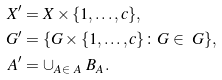Convert formula to latex. <formula><loc_0><loc_0><loc_500><loc_500>X ^ { \prime } & = X \times \{ 1 , \dots , c \} , \\ \ G ^ { \prime } & = \{ G \times \{ 1 , \dots , c \} \colon G \in \ G \} , \\ \ A ^ { \prime } & = \cup _ { A \in \ A } \ B _ { A } .</formula> 